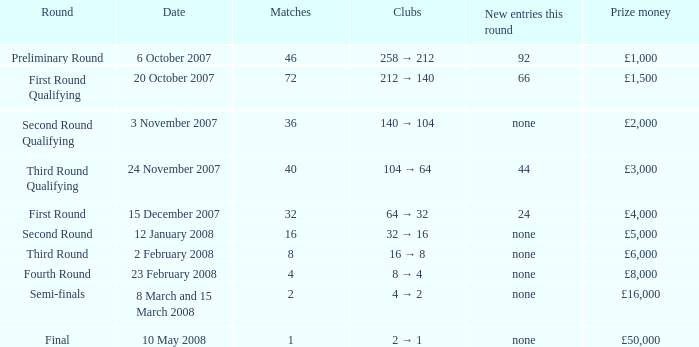What are the clubs with 46 matches? 258 → 212. 